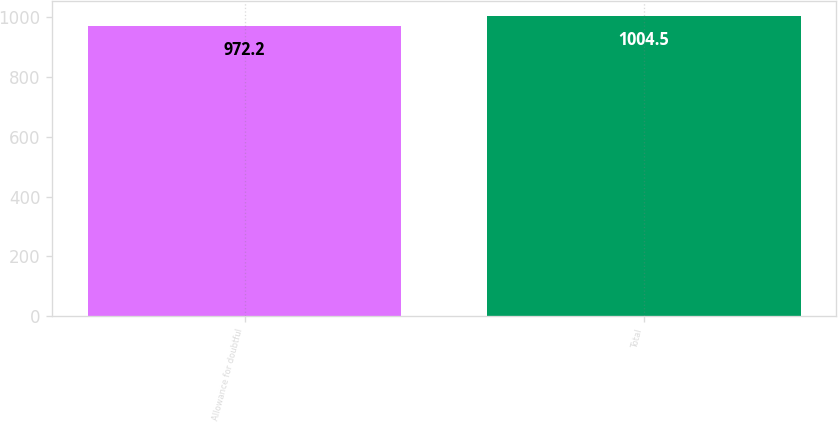Convert chart to OTSL. <chart><loc_0><loc_0><loc_500><loc_500><bar_chart><fcel>Allowance for doubtful<fcel>Total<nl><fcel>972.2<fcel>1004.5<nl></chart> 